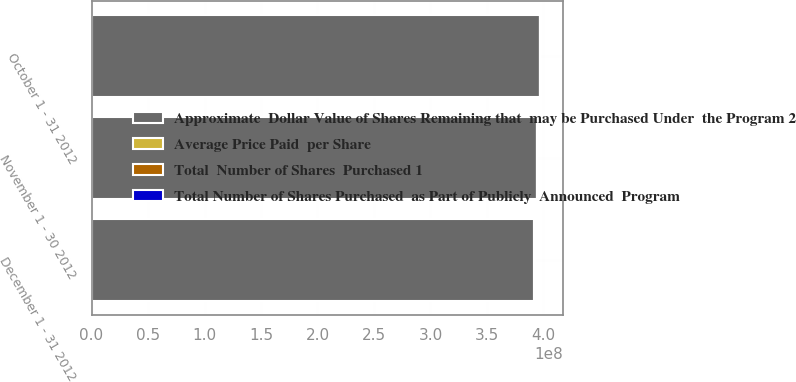<chart> <loc_0><loc_0><loc_500><loc_500><stacked_bar_chart><ecel><fcel>October 1 - 31 2012<fcel>November 1 - 30 2012<fcel>December 1 - 31 2012<nl><fcel>Average Price Paid  per Share<fcel>260208<fcel>64672<fcel>73384<nl><fcel>Total  Number of Shares  Purchased 1<fcel>37.76<fcel>39.35<fcel>43.04<nl><fcel>Total Number of Shares Purchased  as Part of Publicly  Announced  Program<fcel>84236<fcel>63396<fcel>58699<nl><fcel>Approximate  Dollar Value of Shares Remaining that  may be Purchased Under  the Program 2<fcel>3.97e+08<fcel>3.94e+08<fcel>3.92e+08<nl></chart> 